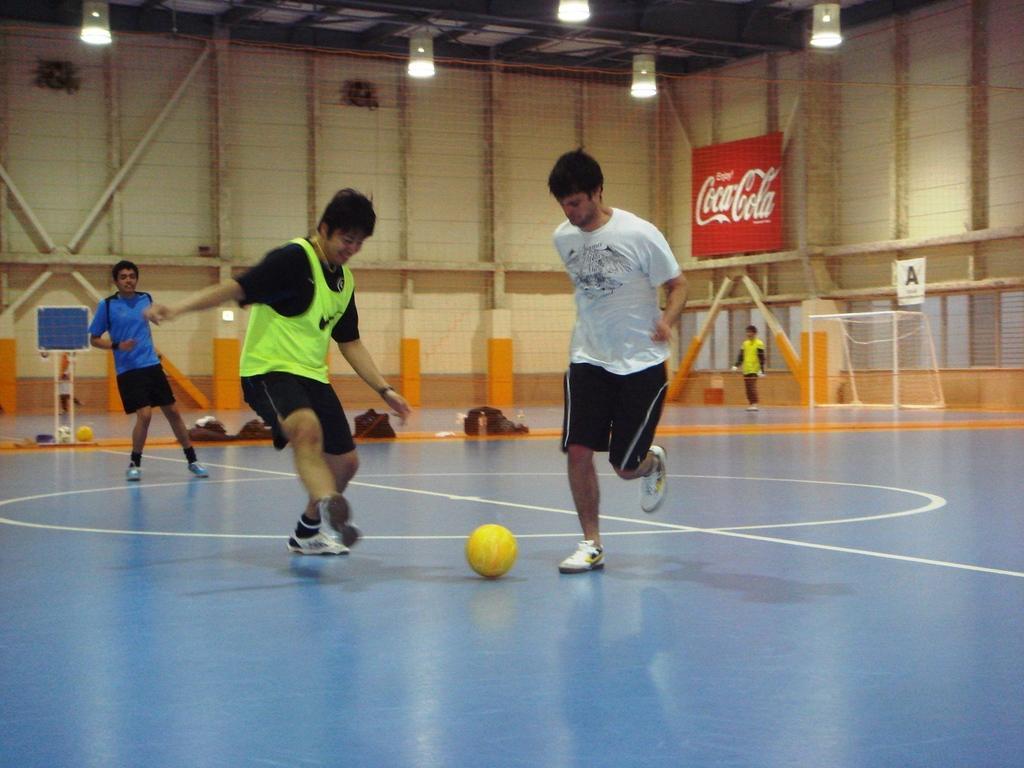How would you summarize this image in a sentence or two? In this image there are three person are playing in the ground as we can see in middle of this image and there is a ball on the floor in the bottom of this image. There is a wall in the background and there are some lights arranged on the top of this image and there is a goal stand on the right side of this image. 